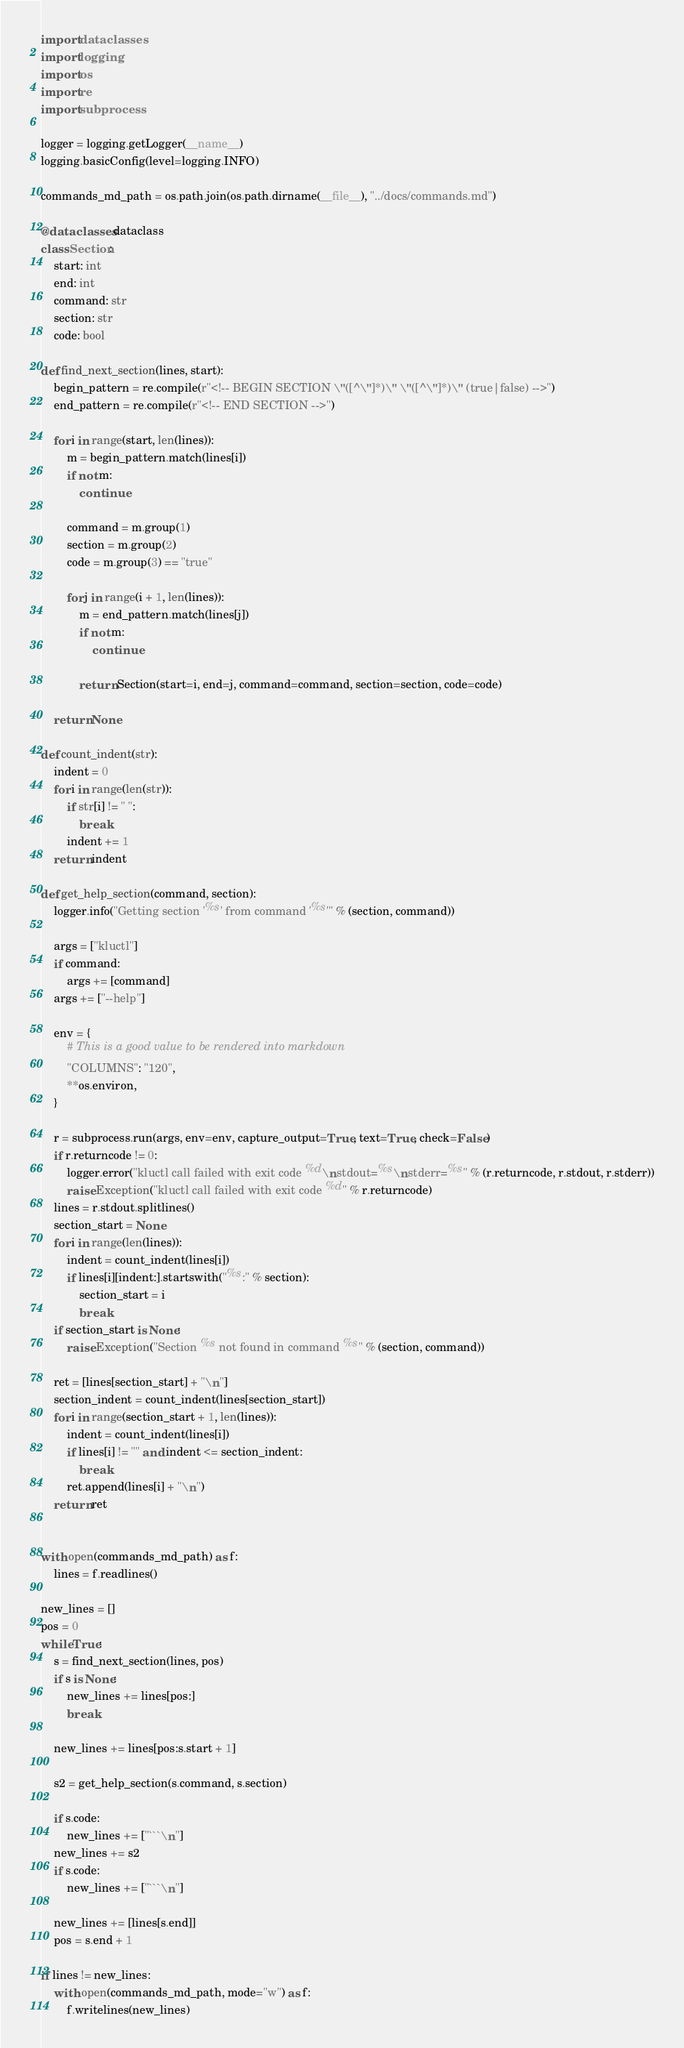Convert code to text. <code><loc_0><loc_0><loc_500><loc_500><_Python_>import dataclasses
import logging
import os
import re
import subprocess

logger = logging.getLogger(__name__)
logging.basicConfig(level=logging.INFO)

commands_md_path = os.path.join(os.path.dirname(__file__), "../docs/commands.md")

@dataclasses.dataclass
class Section:
    start: int
    end: int
    command: str
    section: str
    code: bool

def find_next_section(lines, start):
    begin_pattern = re.compile(r"<!-- BEGIN SECTION \"([^\"]*)\" \"([^\"]*)\" (true|false) -->")
    end_pattern = re.compile(r"<!-- END SECTION -->")

    for i in range(start, len(lines)):
        m = begin_pattern.match(lines[i])
        if not m:
            continue

        command = m.group(1)
        section = m.group(2)
        code = m.group(3) == "true"

        for j in range(i + 1, len(lines)):
            m = end_pattern.match(lines[j])
            if not m:
                continue

            return Section(start=i, end=j, command=command, section=section, code=code)

    return None

def count_indent(str):
    indent = 0
    for i in range(len(str)):
        if str[i] != " ":
            break
        indent += 1
    return indent

def get_help_section(command, section):
    logger.info("Getting section '%s' from command '%s'" % (section, command))

    args = ["kluctl"]
    if command:
        args += [command]
    args += ["--help"]

    env = {
        # This is a good value to be rendered into markdown
        "COLUMNS": "120",
        **os.environ,
    }

    r = subprocess.run(args, env=env, capture_output=True, text=True, check=False)
    if r.returncode != 0:
        logger.error("kluctl call failed with exit code %d\nstdout=%s\nstderr=%s" % (r.returncode, r.stdout, r.stderr))
        raise Exception("kluctl call failed with exit code %d" % r.returncode)
    lines = r.stdout.splitlines()
    section_start = None
    for i in range(len(lines)):
        indent = count_indent(lines[i])
        if lines[i][indent:].startswith("%s:" % section):
            section_start = i
            break
    if section_start is None:
        raise Exception("Section %s not found in command %s" % (section, command))

    ret = [lines[section_start] + "\n"]
    section_indent = count_indent(lines[section_start])
    for i in range(section_start + 1, len(lines)):
        indent = count_indent(lines[i])
        if lines[i] != "" and indent <= section_indent:
            break
        ret.append(lines[i] + "\n")
    return ret


with open(commands_md_path) as f:
    lines = f.readlines()

new_lines = []
pos = 0
while True:
    s = find_next_section(lines, pos)
    if s is None:
        new_lines += lines[pos:]
        break

    new_lines += lines[pos:s.start + 1]

    s2 = get_help_section(s.command, s.section)

    if s.code:
        new_lines += ["```\n"]
    new_lines += s2
    if s.code:
        new_lines += ["```\n"]

    new_lines += [lines[s.end]]
    pos = s.end + 1

if lines != new_lines:
    with open(commands_md_path, mode="w") as f:
        f.writelines(new_lines)
</code> 